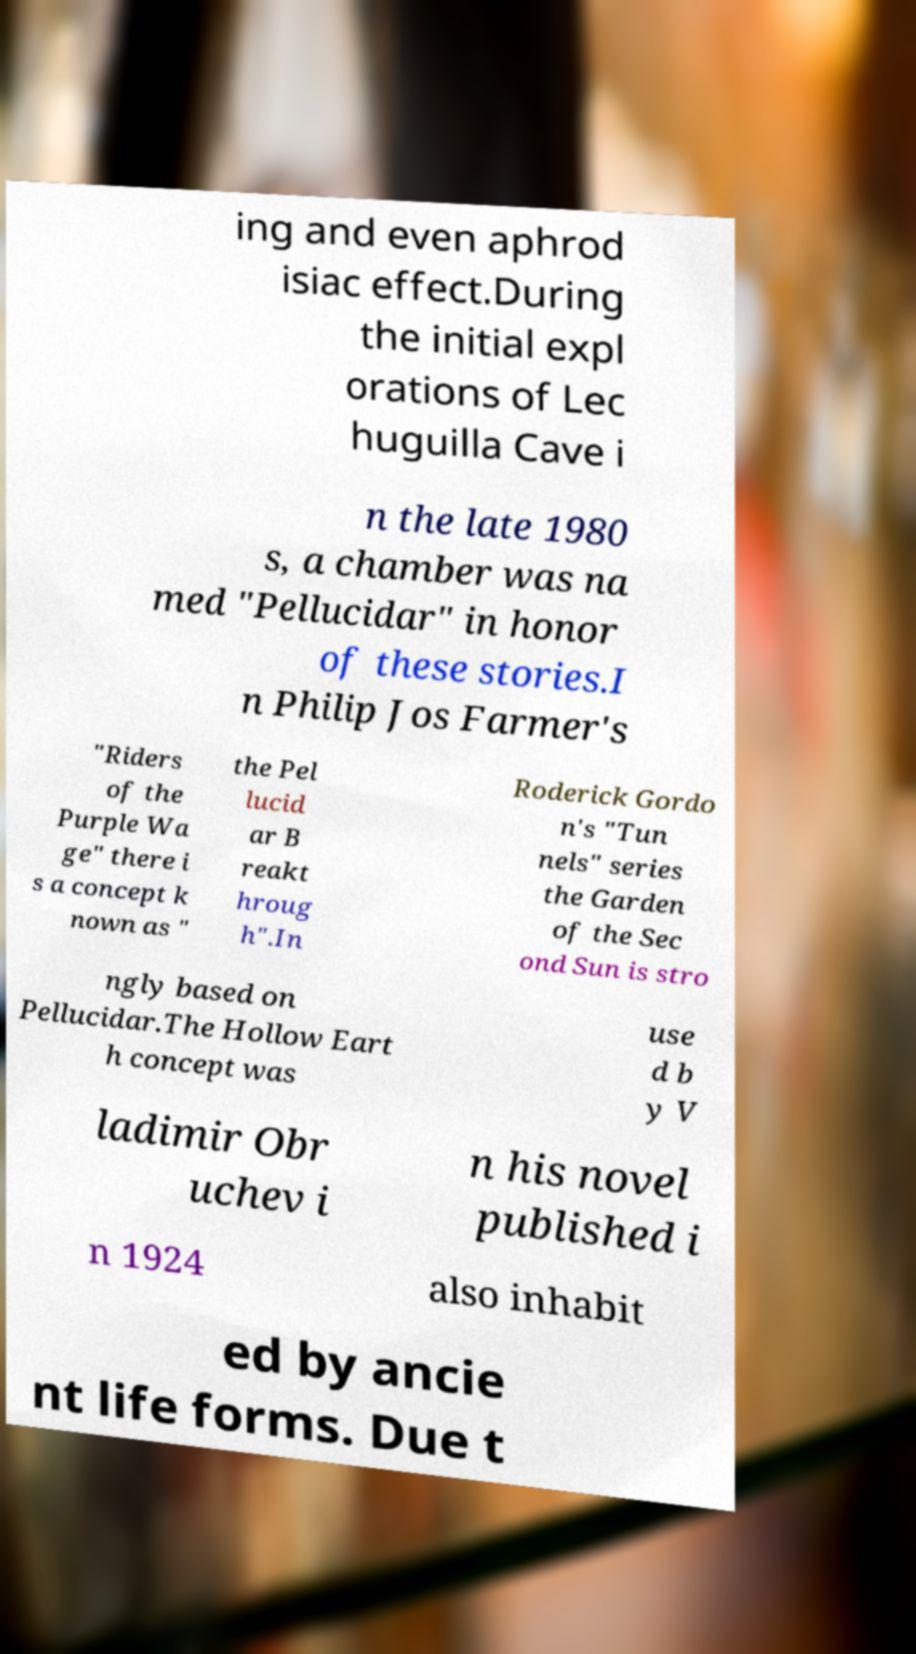What messages or text are displayed in this image? I need them in a readable, typed format. ing and even aphrod isiac effect.During the initial expl orations of Lec huguilla Cave i n the late 1980 s, a chamber was na med "Pellucidar" in honor of these stories.I n Philip Jos Farmer's "Riders of the Purple Wa ge" there i s a concept k nown as " the Pel lucid ar B reakt hroug h".In Roderick Gordo n's "Tun nels" series the Garden of the Sec ond Sun is stro ngly based on Pellucidar.The Hollow Eart h concept was use d b y V ladimir Obr uchev i n his novel published i n 1924 also inhabit ed by ancie nt life forms. Due t 